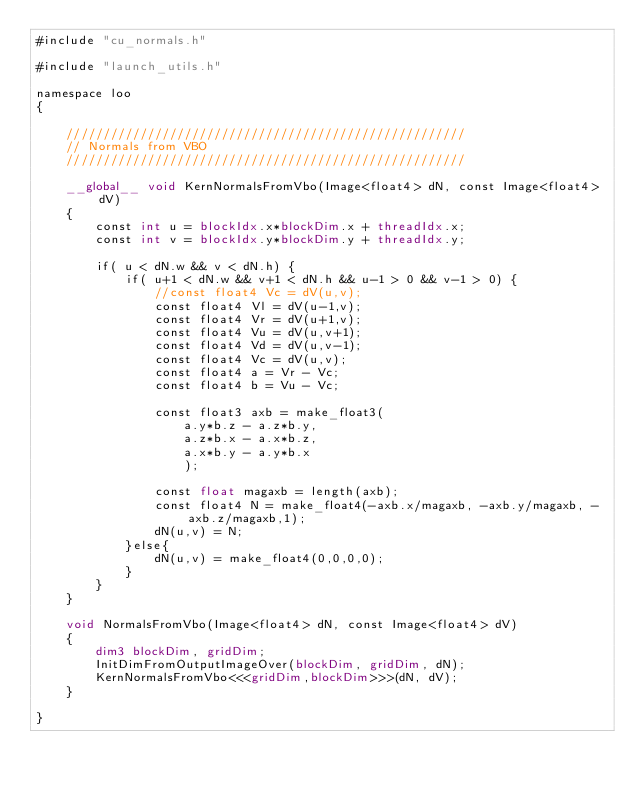Convert code to text. <code><loc_0><loc_0><loc_500><loc_500><_Cuda_>#include "cu_normals.h"

#include "launch_utils.h"

namespace loo
{

	//////////////////////////////////////////////////////
	// Normals from VBO
	//////////////////////////////////////////////////////

	__global__ void KernNormalsFromVbo(Image<float4> dN, const Image<float4> dV)
	{
		const int u = blockIdx.x*blockDim.x + threadIdx.x;
		const int v = blockIdx.y*blockDim.y + threadIdx.y;

		if( u < dN.w && v < dN.h) {
			if( u+1 < dN.w && v+1 < dN.h && u-1 > 0 && v-1 > 0) {
				//const float4 Vc = dV(u,v);
				const float4 Vl = dV(u-1,v);
				const float4 Vr = dV(u+1,v);
				const float4 Vu = dV(u,v+1);
				const float4 Vd = dV(u,v-1);
				const float4 Vc = dV(u,v);
				const float4 a = Vr - Vc;
				const float4 b = Vu - Vc;
				
				const float3 axb = make_float3(
					a.y*b.z - a.z*b.y,
					a.z*b.x - a.x*b.z,
					a.x*b.y - a.y*b.x
					);

				const float magaxb = length(axb);
				const float4 N = make_float4(-axb.x/magaxb, -axb.y/magaxb, -axb.z/magaxb,1);
				dN(u,v) = N;
			}else{
				dN(u,v) = make_float4(0,0,0,0);
			}
		}
	}

	void NormalsFromVbo(Image<float4> dN, const Image<float4> dV)
	{
		dim3 blockDim, gridDim;
		InitDimFromOutputImageOver(blockDim, gridDim, dN);
		KernNormalsFromVbo<<<gridDim,blockDim>>>(dN, dV);
	}

}
</code> 